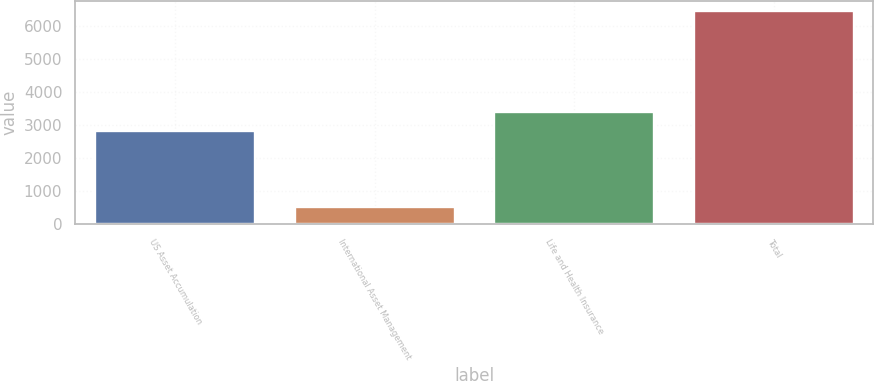<chart> <loc_0><loc_0><loc_500><loc_500><bar_chart><fcel>US Asset Accumulation<fcel>International Asset Management<fcel>Life and Health Insurance<fcel>Total<nl><fcel>2807.7<fcel>526.7<fcel>3398.56<fcel>6435.3<nl></chart> 